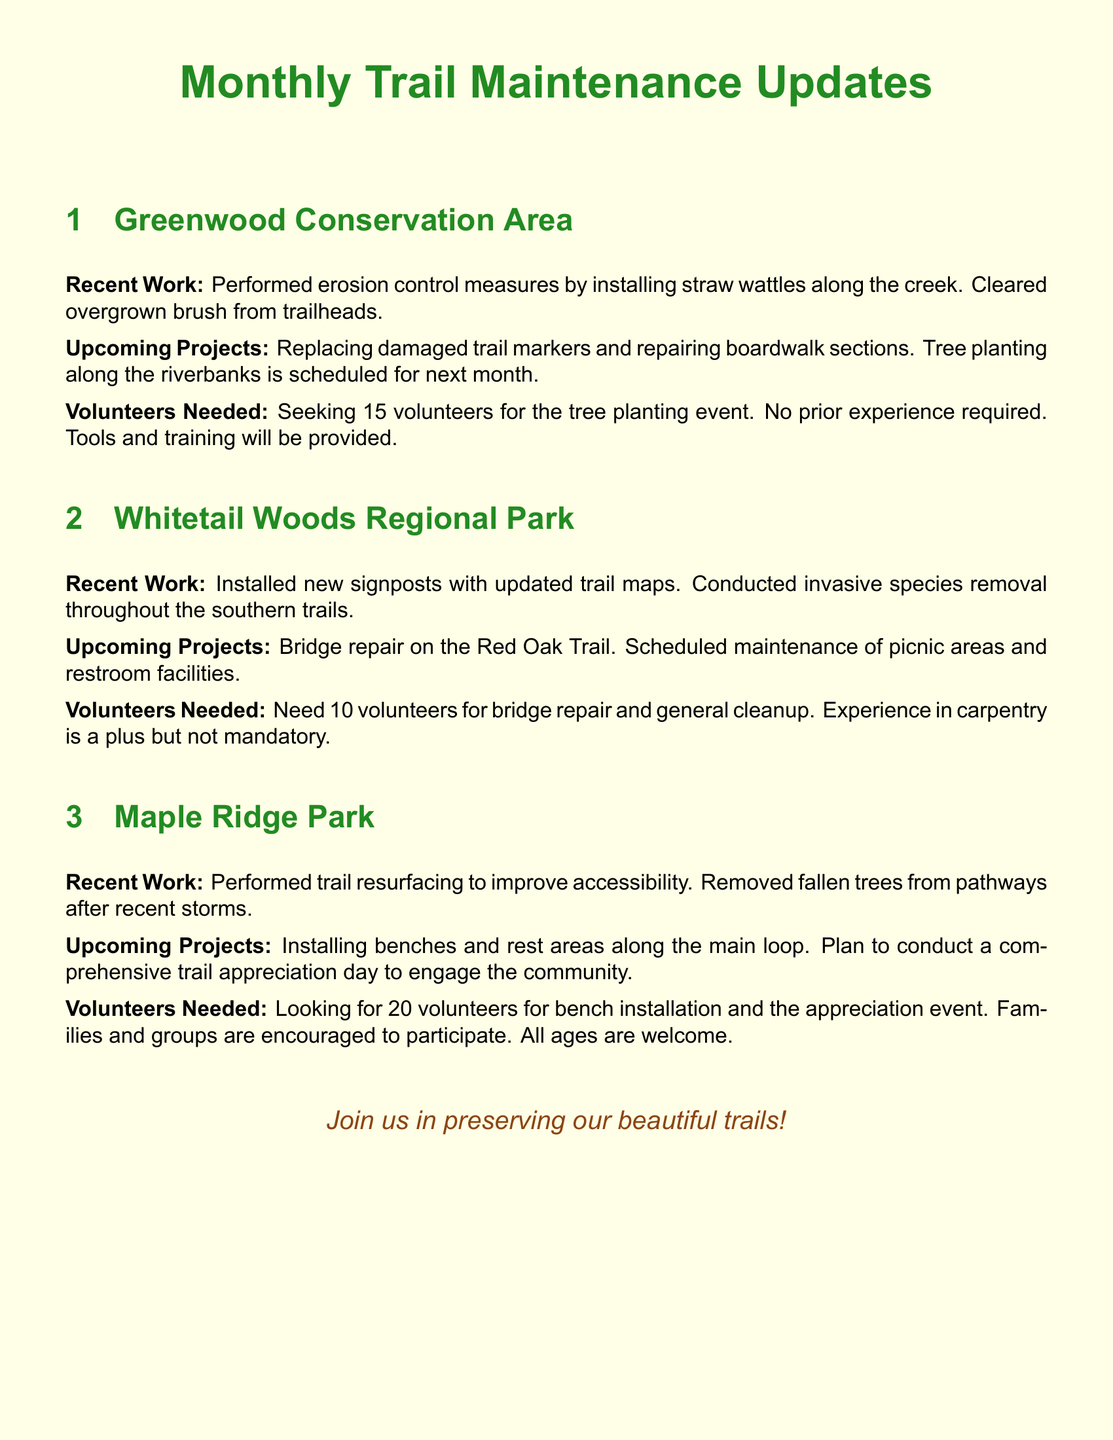What recent work was done in the Greenwood Conservation Area? Recent work includes installing straw wattles along the creek and clearing overgrown brush from trailheads.
Answer: Installing straw wattles and clearing overgrown brush How many volunteers are needed for the tree planting event at Greenwood Conservation Area? The document states that 15 volunteers are needed for the tree planting event.
Answer: 15 volunteers What is scheduled for the next month at the Greenwood Conservation Area? The upcoming project includes tree planting along the riverbanks next month.
Answer: Tree planting What specific maintenance will be performed at Whitetail Woods Regional Park? Scheduled maintenance at Whitetail Woods includes bridge repair and maintaining picnic areas and restroom facilities.
Answer: Bridge repair and picnic area maintenance How many volunteers are sought for bridge repair at Whitetail Woods? The document mentions that 10 volunteers are needed for bridge repair.
Answer: 10 volunteers What was removed throughout the southern trails of Whitetail Woods? Invasive species were removed throughout the southern trails.
Answer: Invasive species What is the total number of volunteers needed for Maple Ridge Park projects? The document specifies looking for 20 volunteers for bench installation and appreciation events.
Answer: 20 volunteers What event is planned to engage the community in Maple Ridge Park? A comprehensive trail appreciation day is planned to engage the community.
Answer: Trail appreciation day What type of experience is preferred but not mandatory for Whitetail Woods volunteers? Experience in carpentry is preferred but not mandatory for the volunteers working on bridge repair.
Answer: Carpentry experience What color is used for the document header? The header color used in the document is forest green.
Answer: Forest green 